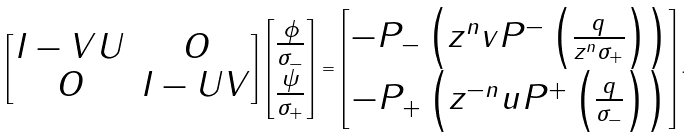<formula> <loc_0><loc_0><loc_500><loc_500>\begin{bmatrix} I - V U & O \\ O & I - U V \end{bmatrix} \begin{bmatrix} \frac { \phi } { \sigma _ { - } } \\ \frac { \psi } { \sigma _ { + } } \end{bmatrix} = \begin{bmatrix} - P _ { - } \left ( z ^ { n } v P ^ { - } \left ( \frac { q } { z ^ { n } \sigma _ { + } } \right ) \right ) \\ - P _ { + } \left ( z ^ { - n } u P ^ { + } \left ( \frac { q } { \sigma _ { - } } \right ) \right ) \end{bmatrix} .</formula> 